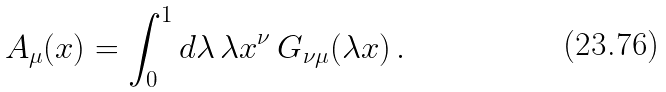Convert formula to latex. <formula><loc_0><loc_0><loc_500><loc_500>A _ { \mu } ( x ) = \int _ { 0 } ^ { 1 } d \lambda \, \lambda x ^ { \nu } \, G _ { \nu \mu } ( \lambda x ) \, .</formula> 